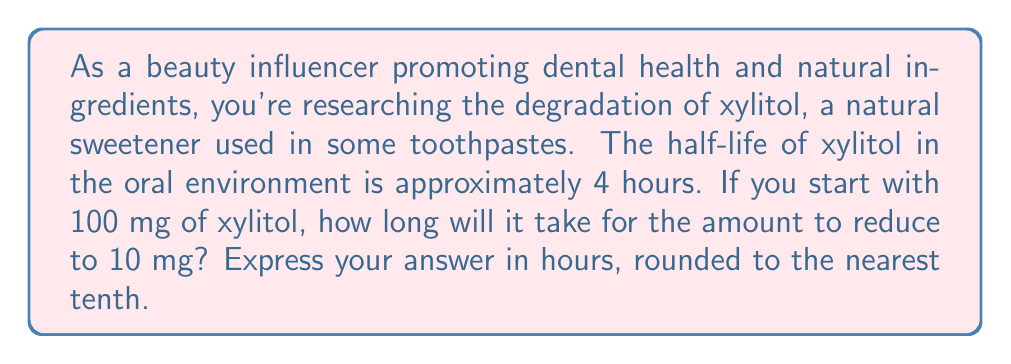Teach me how to tackle this problem. To solve this problem, we'll use the exponential decay formula and logarithms. Let's break it down step-by-step:

1) The exponential decay formula is:
   $A(t) = A_0 \cdot (\frac{1}{2})^{\frac{t}{t_{1/2}}}$

   Where:
   $A(t)$ is the amount remaining after time $t$
   $A_0$ is the initial amount
   $t$ is the time elapsed
   $t_{1/2}$ is the half-life

2) We know:
   $A_0 = 100$ mg
   $A(t) = 10$ mg
   $t_{1/2} = 4$ hours

3) Let's substitute these into our formula:
   $10 = 100 \cdot (\frac{1}{2})^{\frac{t}{4}}$

4) Divide both sides by 100:
   $\frac{1}{10} = (\frac{1}{2})^{\frac{t}{4}}$

5) Take the logarithm (base 2) of both sides:
   $\log_2(\frac{1}{10}) = \frac{t}{4}$

6) Multiply both sides by 4:
   $4 \cdot \log_2(\frac{1}{10}) = t$

7) We can change this to natural log:
   $t = 4 \cdot \frac{\ln(\frac{1}{10})}{\ln(2)}$

8) Calculate:
   $t = 4 \cdot \frac{\ln(0.1)}{\ln(2)} \approx 13.288$ hours

9) Rounding to the nearest tenth:
   $t \approx 13.3$ hours
Answer: 13.3 hours 